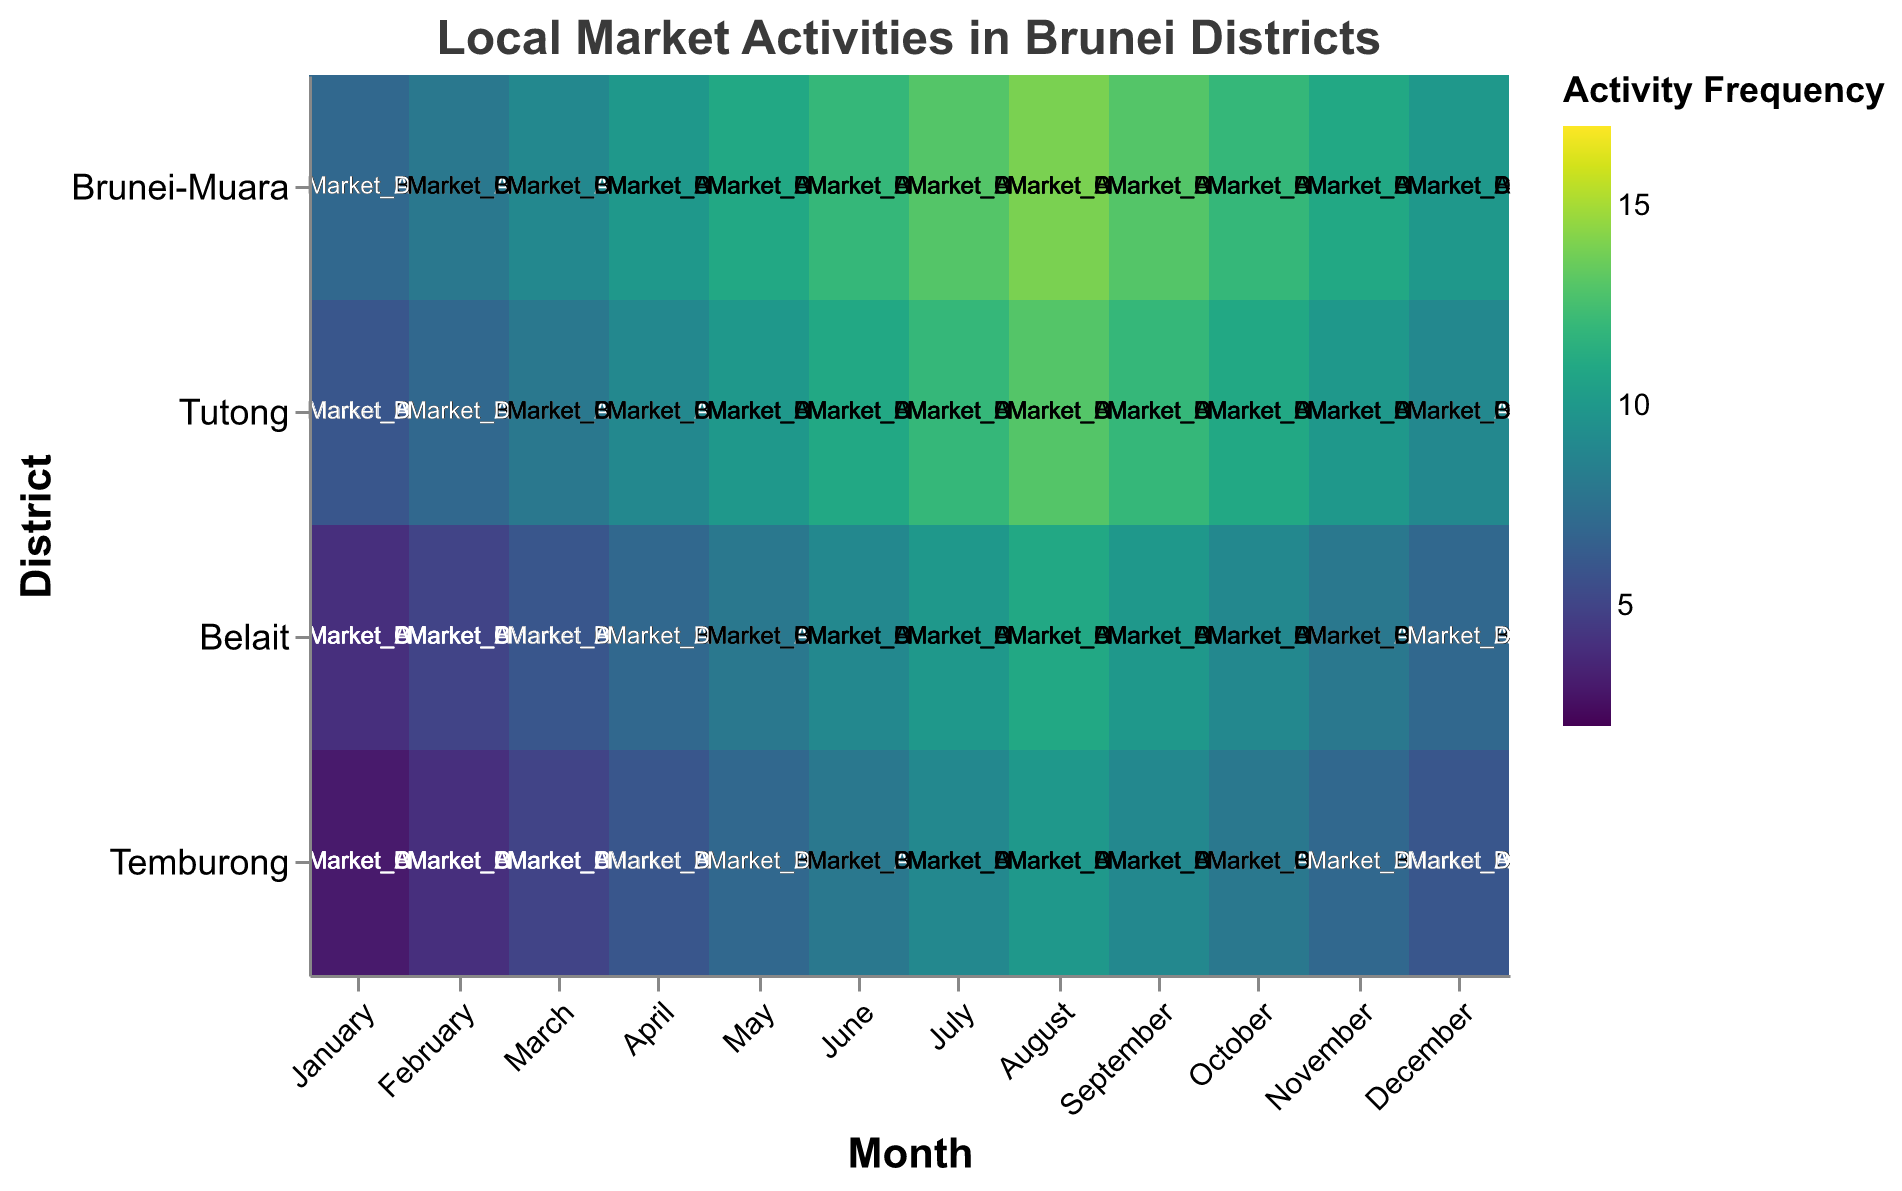What is the title of the heatmap? The title is usually located at the top of the heatmap and provides a brief description of the data being visualized. In this case, it should read "Local Market Activities in Brunei Districts".
Answer: Local Market Activities in Brunei Districts Which district has the highest market activity in August for Market_A? To determine this, look at the August column and compare the activity frequency in the Market_A row for each district. Brunei-Muara is shown to have the highest activity frequency with a value of 12.
Answer: Brunei-Muara During which month do Tutong and Temburong have the same market activity for Market_B? Compare the values in the Market_B row for both Tutong and Temburong across all months. They have the same value of 14 in August.
Answer: August How does the activity frequency for Market_C change in Brunei-Muara from January to December? Examine the Market_C row for Brunei-Muara from January to December. The frequency starts at 10 in January, rises to a peak of 17 in August, and then falls back to 13 in December.
Answer: Starts at 10, peaks at 17 in August, ends at 13 Which month shows the maximum market activity for Market_D in Belait? Check the values in the Market_D row for Belait across all months. The maximum value is 11, which occurs in August.
Answer: August What are the frequencies for Market_D in Temburong in July and September, and what is their difference? Look at the July and September values for Market_D in Temburong. The frequencies are 9 and 9 respectively, resulting in a difference of 0.
Answer: 0 Which market shows the most variation in frequency across the months in Brunei-Muara? Compare the range (maximum value minus minimum value) for each market. Market_C varies from 10 to 17, a difference of 7, which is higher than any other market in Brunei-Muara.
Answer: Market_C Is there any month where all four districts have the same frequency for Market_A? Examine the Market_A row across all districts for each month. There are no months where all four districts have the same frequency in Market_A.
Answer: No Between Belait and Temburong, which district has a higher overall frequency for Market_B in June? Compare the Market_B frequencies for Belait (10) and Temburong (9) in June. Belait has the higher frequency.
Answer: Belait 